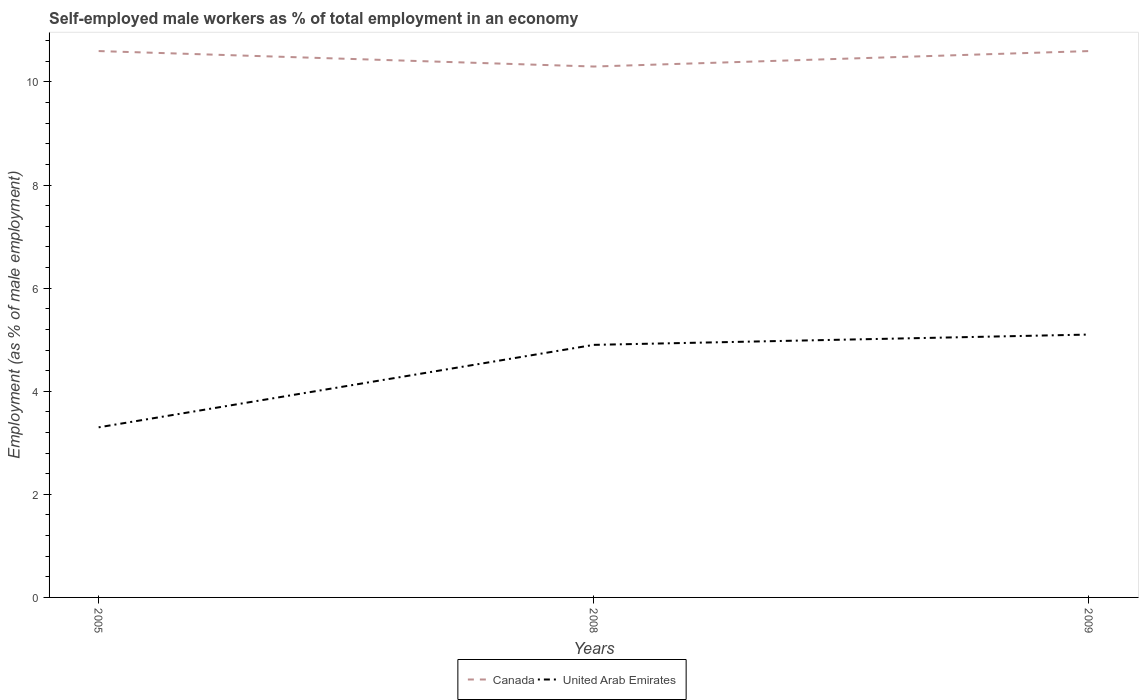How many different coloured lines are there?
Make the answer very short. 2. Does the line corresponding to Canada intersect with the line corresponding to United Arab Emirates?
Give a very brief answer. No. Is the number of lines equal to the number of legend labels?
Your answer should be compact. Yes. Across all years, what is the maximum percentage of self-employed male workers in Canada?
Provide a short and direct response. 10.3. In which year was the percentage of self-employed male workers in United Arab Emirates maximum?
Keep it short and to the point. 2005. What is the total percentage of self-employed male workers in United Arab Emirates in the graph?
Give a very brief answer. -0.2. What is the difference between the highest and the second highest percentage of self-employed male workers in United Arab Emirates?
Offer a terse response. 1.8. What is the difference between the highest and the lowest percentage of self-employed male workers in United Arab Emirates?
Provide a short and direct response. 2. How many lines are there?
Your answer should be very brief. 2. What is the difference between two consecutive major ticks on the Y-axis?
Ensure brevity in your answer.  2. Does the graph contain any zero values?
Provide a succinct answer. No. Does the graph contain grids?
Make the answer very short. No. How many legend labels are there?
Provide a short and direct response. 2. How are the legend labels stacked?
Your answer should be very brief. Horizontal. What is the title of the graph?
Offer a terse response. Self-employed male workers as % of total employment in an economy. What is the label or title of the Y-axis?
Offer a terse response. Employment (as % of male employment). What is the Employment (as % of male employment) in Canada in 2005?
Offer a terse response. 10.6. What is the Employment (as % of male employment) of United Arab Emirates in 2005?
Your response must be concise. 3.3. What is the Employment (as % of male employment) in Canada in 2008?
Ensure brevity in your answer.  10.3. What is the Employment (as % of male employment) of United Arab Emirates in 2008?
Offer a terse response. 4.9. What is the Employment (as % of male employment) in Canada in 2009?
Offer a very short reply. 10.6. What is the Employment (as % of male employment) in United Arab Emirates in 2009?
Your response must be concise. 5.1. Across all years, what is the maximum Employment (as % of male employment) in Canada?
Make the answer very short. 10.6. Across all years, what is the maximum Employment (as % of male employment) in United Arab Emirates?
Give a very brief answer. 5.1. Across all years, what is the minimum Employment (as % of male employment) of Canada?
Provide a short and direct response. 10.3. Across all years, what is the minimum Employment (as % of male employment) of United Arab Emirates?
Provide a short and direct response. 3.3. What is the total Employment (as % of male employment) in Canada in the graph?
Your answer should be compact. 31.5. What is the difference between the Employment (as % of male employment) of Canada in 2005 and that in 2008?
Make the answer very short. 0.3. What is the difference between the Employment (as % of male employment) of United Arab Emirates in 2005 and that in 2008?
Offer a very short reply. -1.6. What is the difference between the Employment (as % of male employment) in Canada in 2008 and that in 2009?
Offer a terse response. -0.3. What is the difference between the Employment (as % of male employment) of Canada in 2005 and the Employment (as % of male employment) of United Arab Emirates in 2009?
Ensure brevity in your answer.  5.5. What is the difference between the Employment (as % of male employment) of Canada in 2008 and the Employment (as % of male employment) of United Arab Emirates in 2009?
Make the answer very short. 5.2. What is the average Employment (as % of male employment) of Canada per year?
Your answer should be very brief. 10.5. What is the average Employment (as % of male employment) in United Arab Emirates per year?
Provide a succinct answer. 4.43. In the year 2009, what is the difference between the Employment (as % of male employment) of Canada and Employment (as % of male employment) of United Arab Emirates?
Offer a terse response. 5.5. What is the ratio of the Employment (as % of male employment) in Canada in 2005 to that in 2008?
Your answer should be very brief. 1.03. What is the ratio of the Employment (as % of male employment) in United Arab Emirates in 2005 to that in 2008?
Give a very brief answer. 0.67. What is the ratio of the Employment (as % of male employment) in Canada in 2005 to that in 2009?
Your answer should be compact. 1. What is the ratio of the Employment (as % of male employment) of United Arab Emirates in 2005 to that in 2009?
Make the answer very short. 0.65. What is the ratio of the Employment (as % of male employment) of Canada in 2008 to that in 2009?
Ensure brevity in your answer.  0.97. What is the ratio of the Employment (as % of male employment) in United Arab Emirates in 2008 to that in 2009?
Make the answer very short. 0.96. What is the difference between the highest and the second highest Employment (as % of male employment) of Canada?
Ensure brevity in your answer.  0. What is the difference between the highest and the lowest Employment (as % of male employment) in Canada?
Provide a short and direct response. 0.3. 